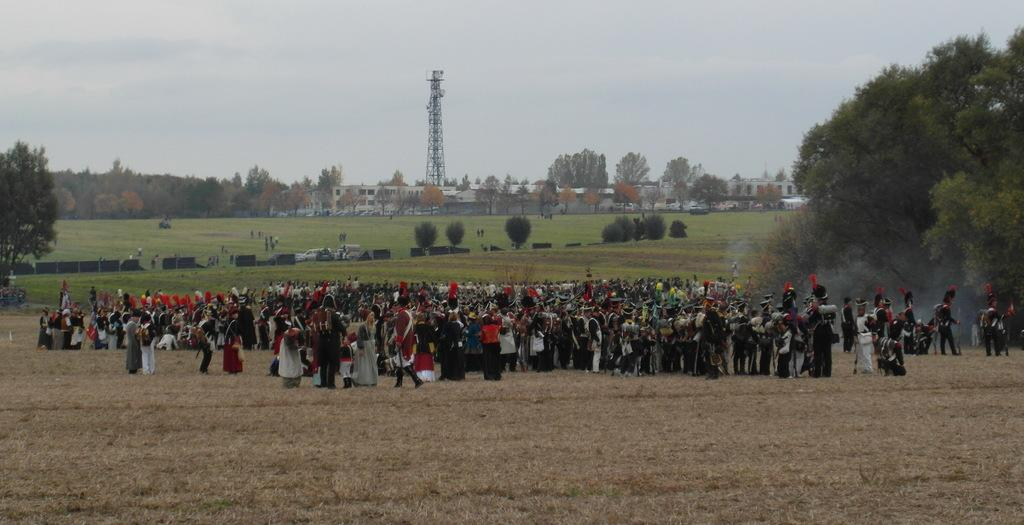What is the main subject in the middle of the image? There are many people in the middle of the image. What type of terrain is visible at the bottom of the image? There is grass at the bottom of the image. What can be seen in the background of the image? There are trees, houses, a tower, people, vehicles, the sky, and clouds in the background of the image. What type of cake is being served to the hen in the image? There is no hen or cake present in the image. What type of apparel are the people wearing in the image? The provided facts do not mention the apparel of the people in the image. 